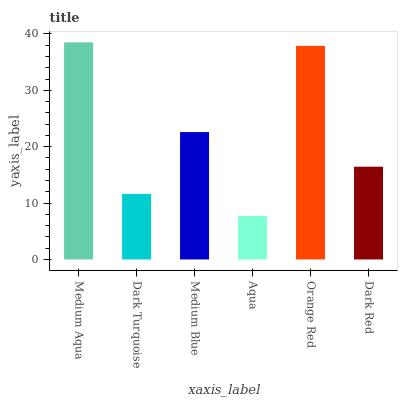Is Aqua the minimum?
Answer yes or no. Yes. Is Medium Aqua the maximum?
Answer yes or no. Yes. Is Dark Turquoise the minimum?
Answer yes or no. No. Is Dark Turquoise the maximum?
Answer yes or no. No. Is Medium Aqua greater than Dark Turquoise?
Answer yes or no. Yes. Is Dark Turquoise less than Medium Aqua?
Answer yes or no. Yes. Is Dark Turquoise greater than Medium Aqua?
Answer yes or no. No. Is Medium Aqua less than Dark Turquoise?
Answer yes or no. No. Is Medium Blue the high median?
Answer yes or no. Yes. Is Dark Red the low median?
Answer yes or no. Yes. Is Aqua the high median?
Answer yes or no. No. Is Medium Aqua the low median?
Answer yes or no. No. 